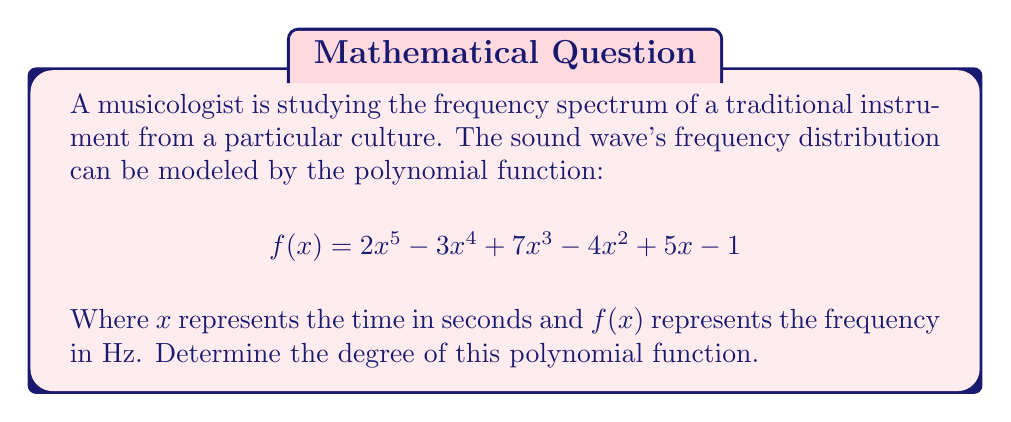Can you answer this question? To determine the degree of a polynomial function, we need to identify the highest power of the variable (in this case, $x$) in the function.

Let's examine each term of the polynomial:

1. $2x^5$: The exponent of $x$ is 5
2. $-3x^4$: The exponent of $x$ is 4
3. $7x^3$: The exponent of $x$ is 3
4. $-4x^2$: The exponent of $x$ is 2
5. $5x$: The exponent of $x$ is 1 (often omitted in writing)
6. $-1$: This is a constant term, so the exponent of $x$ is 0

The highest exponent among all terms is 5, which appears in the first term $2x^5$.

In polynomial functions, the degree is defined as the highest power of the variable. Therefore, the degree of this polynomial function is 5.

This high degree polynomial suggests that the frequency spectrum of the instrument being studied is complex, potentially capturing nuanced changes in frequency over time, which could be relevant to the musicologist's analysis of rhythmic structures in different cultures.
Answer: The degree of the polynomial function is 5. 